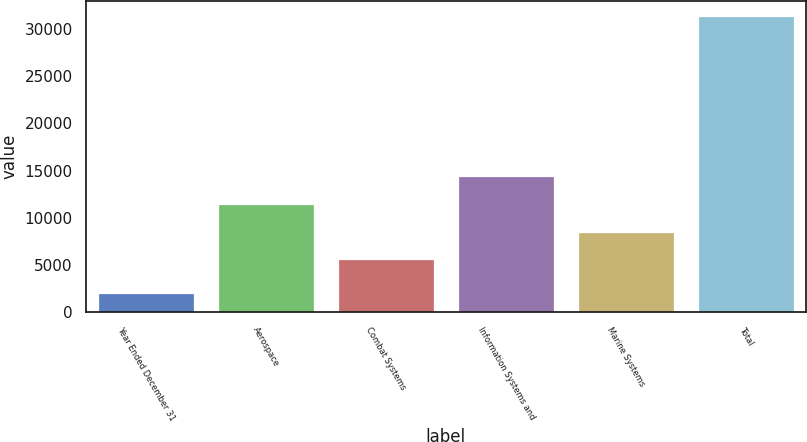Convert chart to OTSL. <chart><loc_0><loc_0><loc_500><loc_500><bar_chart><fcel>Year Ended December 31<fcel>Aerospace<fcel>Combat Systems<fcel>Information Systems and<fcel>Marine Systems<fcel>Total<nl><fcel>2016<fcel>11469.4<fcel>5602<fcel>14403.1<fcel>8535.7<fcel>31353<nl></chart> 